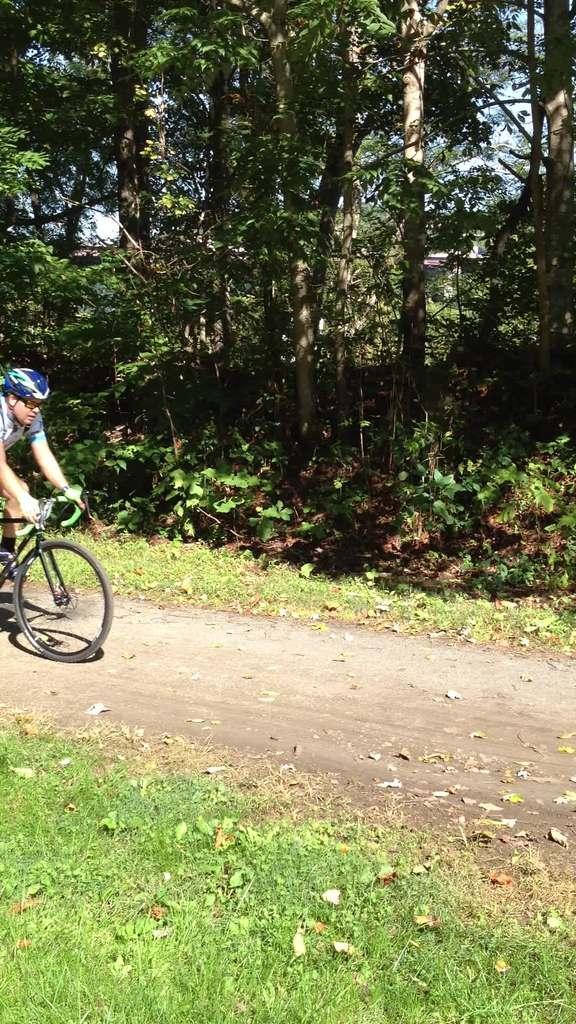Describe this image in one or two sentences. In this image there is a person who is riding a cycle. There is grass. There is sand. There are trees. There is a sky. 